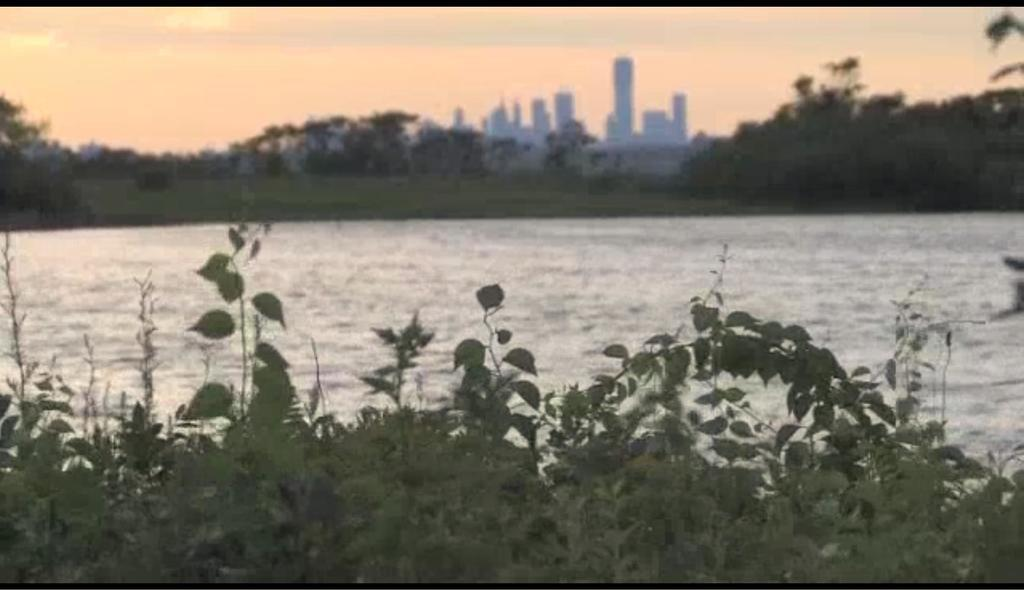What type of living organisms can be seen in the image? Plants and trees are visible in the image. What is the primary element visible in the image? Water is visible in the image. What type of structures can be seen beside the water? There are buildings beside the water. What is visible in the background of the image? The sky is visible in the background of the image. How many pigs are swimming in the water in the image? There are no pigs present in the image; it features plants, trees, water, buildings, and the sky. 